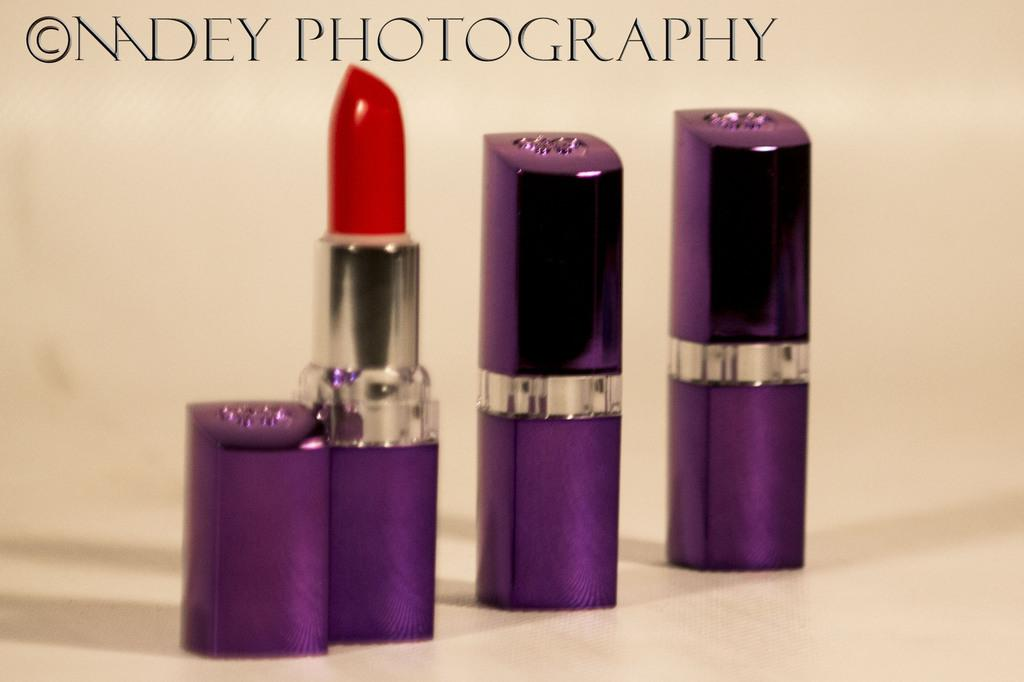What objects are in the foreground of the image? There are three lipstick bottles in the foreground of the image. Where are the lipstick bottles located? The lipstick bottles are on the floor. What can be seen in addition to the lipstick bottles in the image? There is text visible in the image. Can you describe the setting of the image? The image is taken in a room. What type of dinner is being served in the image? There is no dinner present in the image; it features three lipstick bottles on the floor in a room. 